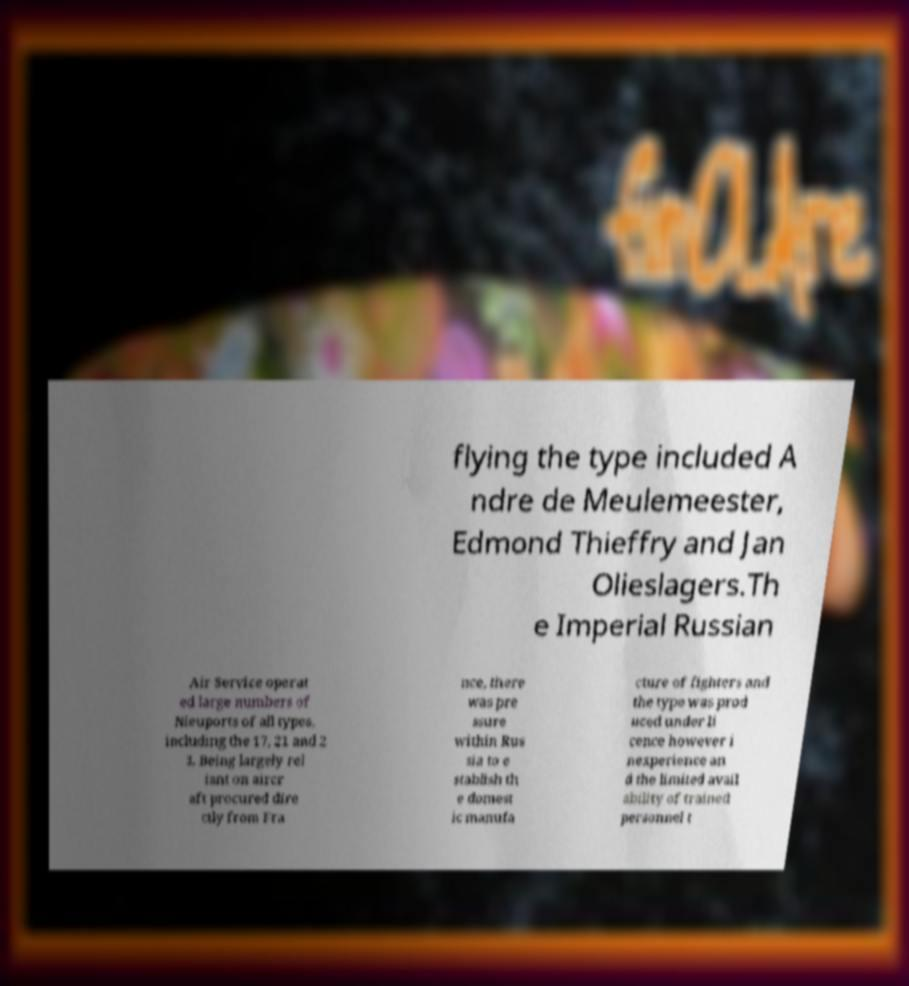What messages or text are displayed in this image? I need them in a readable, typed format. flying the type included A ndre de Meulemeester, Edmond Thieffry and Jan Olieslagers.Th e Imperial Russian Air Service operat ed large numbers of Nieuports of all types, including the 17, 21 and 2 3. Being largely rel iant on aircr aft procured dire ctly from Fra nce, there was pre ssure within Rus sia to e stablish th e domest ic manufa cture of fighters and the type was prod uced under li cence however i nexperience an d the limited avail ability of trained personnel t 